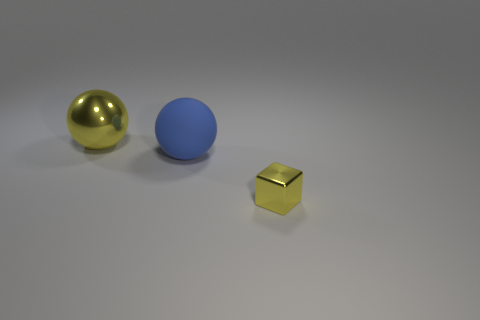Add 3 large rubber things. How many objects exist? 6 Subtract all cubes. How many objects are left? 2 Add 1 tiny cubes. How many tiny cubes exist? 2 Subtract 1 yellow spheres. How many objects are left? 2 Subtract all yellow metallic balls. Subtract all large blue matte spheres. How many objects are left? 1 Add 2 blue things. How many blue things are left? 3 